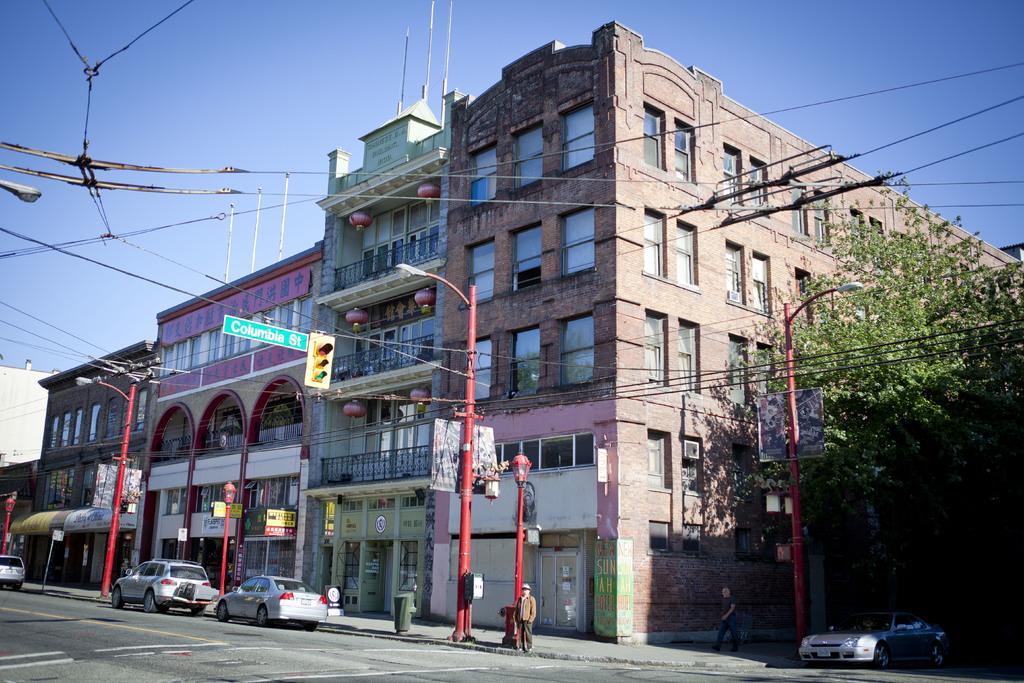Can you describe this image briefly? In this picture there are buildings in the middle of the image. On the right side of the image there is a tree. There are poles on the footpath and there are two persons on the footpath. There are vehicles on the road. At the top there is sky and there are wires. At the bottom there is a road. 